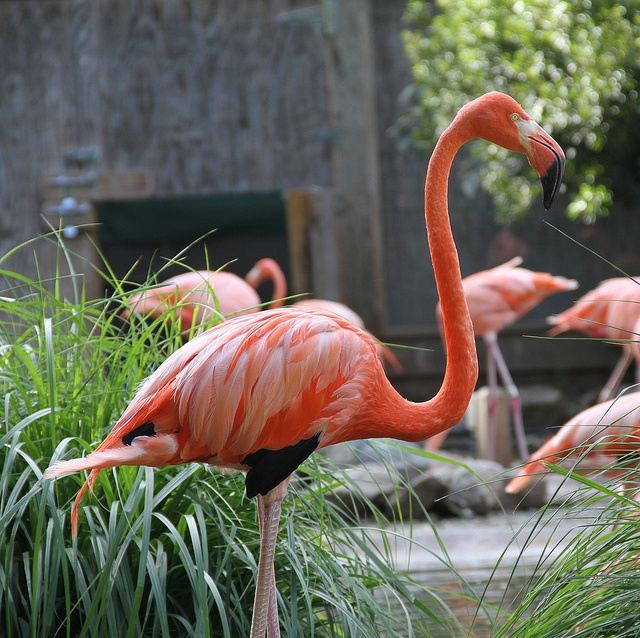Describe the objects in this image and their specific colors. I can see bird in black, brown, and lightpink tones, bird in black, pink, lightpink, olive, and brown tones, bird in black, brown, lightpink, gray, and pink tones, bird in black, lavender, brown, lightpink, and darkgray tones, and bird in black, lightpink, brown, pink, and gray tones in this image. 